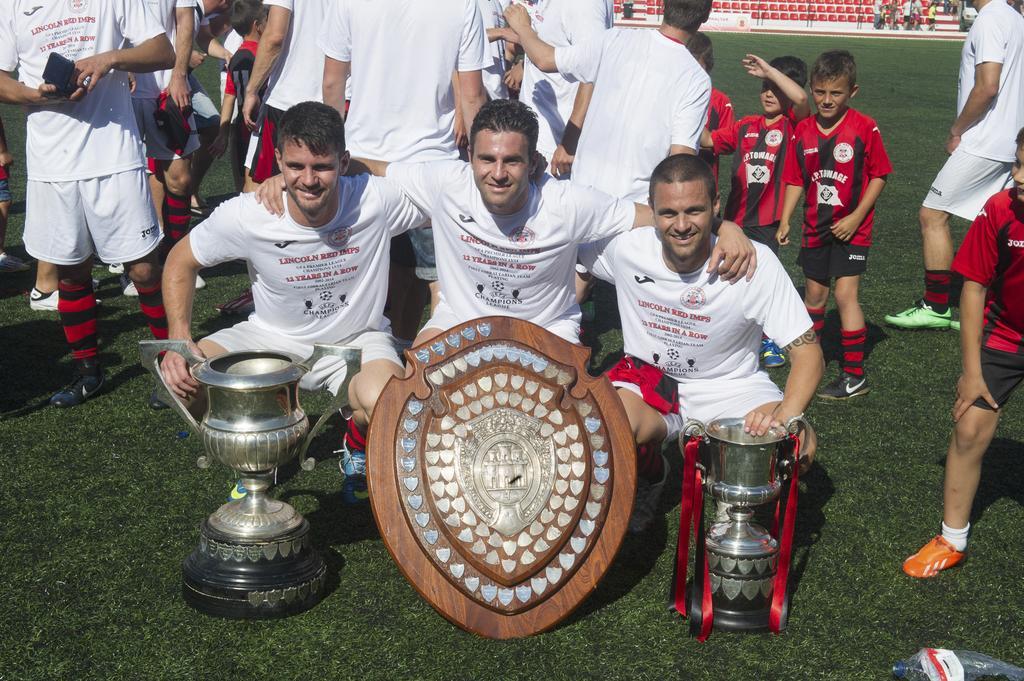In one or two sentences, can you explain what this image depicts? In this picture I can see trophies and a shield, there are three persons in the squat positions, there are group of people standing, and in the background there are chairs. 